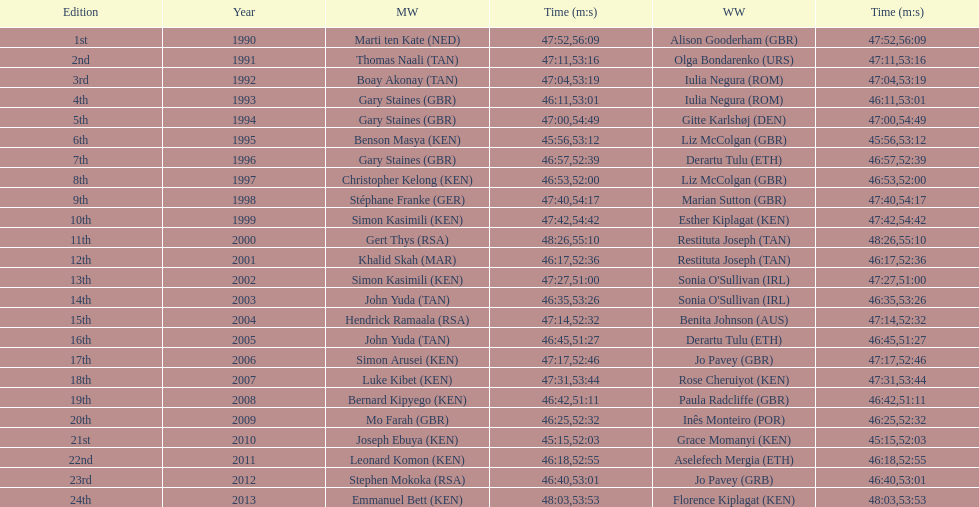Number of men's winners with a finish time under 46:58 12. 